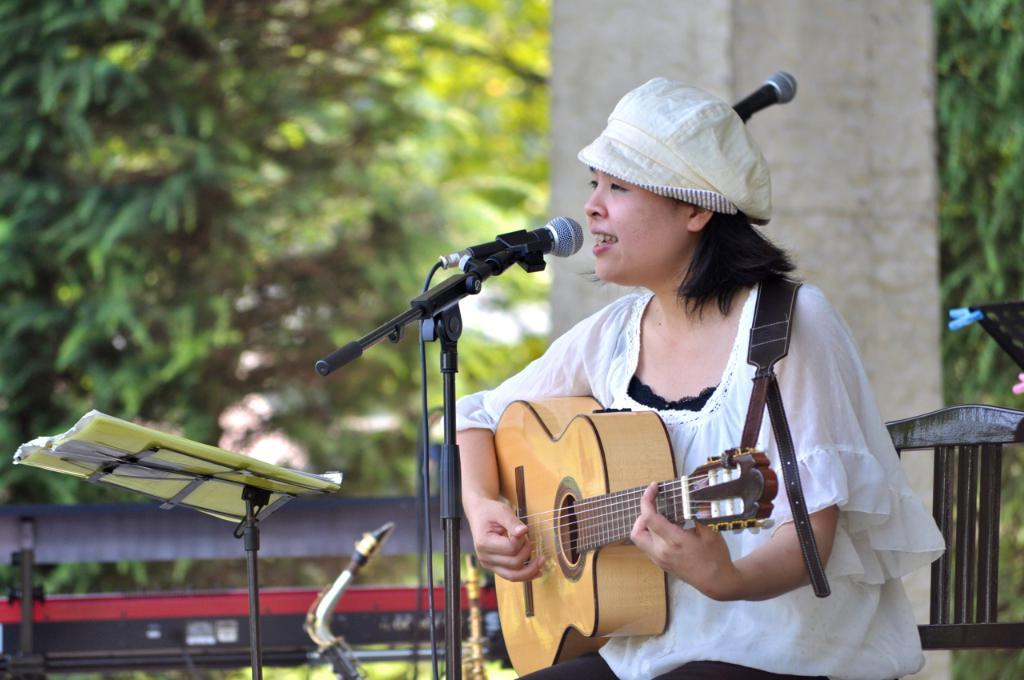What is the woman in the image doing? The woman is singing and holding a guitar. What object is she using to amplify her voice? She is in front of a microphone. What can be seen in the background of the image? There is a pillar and a tree in the background of the image. What type of sweater is the woman wearing in the image? The image does not show the woman wearing a sweater, so it cannot be determined from the image. 